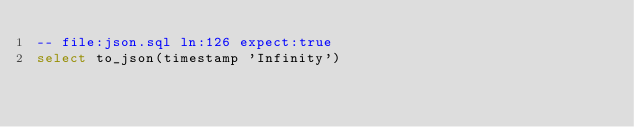Convert code to text. <code><loc_0><loc_0><loc_500><loc_500><_SQL_>-- file:json.sql ln:126 expect:true
select to_json(timestamp 'Infinity')
</code> 